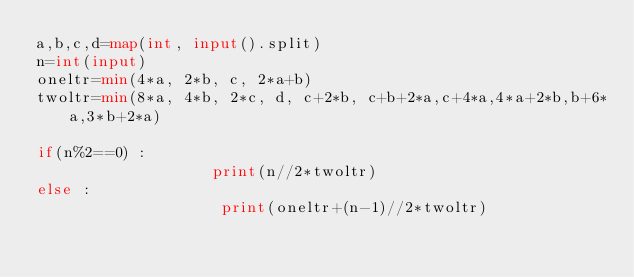Convert code to text. <code><loc_0><loc_0><loc_500><loc_500><_Python_>a,b,c,d=map(int, input().split)
n=int(input)
oneltr=min(4*a, 2*b, c, 2*a+b)
twoltr=min(8*a, 4*b, 2*c, d, c+2*b, c+b+2*a,c+4*a,4*a+2*b,b+6*a,3*b+2*a)

if(n%2==0) :
                   print(n//2*twoltr)
else :
                    print(oneltr+(n-1)//2*twoltr)
</code> 